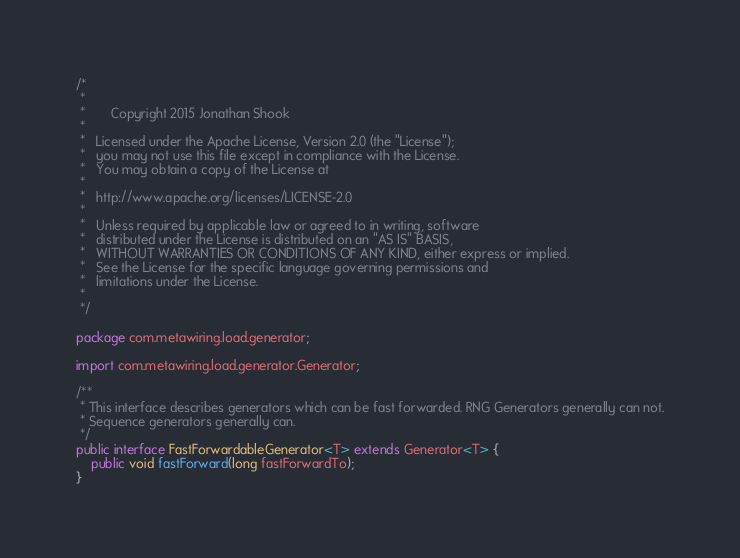<code> <loc_0><loc_0><loc_500><loc_500><_Java_>/*
 *
 *       Copyright 2015 Jonathan Shook
 *
 *   Licensed under the Apache License, Version 2.0 (the "License");
 *   you may not use this file except in compliance with the License.
 *   You may obtain a copy of the License at
 *
 *   http://www.apache.org/licenses/LICENSE-2.0
 *
 *   Unless required by applicable law or agreed to in writing, software
 *   distributed under the License is distributed on an "AS IS" BASIS,
 *   WITHOUT WARRANTIES OR CONDITIONS OF ANY KIND, either express or implied.
 *   See the License for the specific language governing permissions and
 *   limitations under the License.
 *
 */

package com.metawiring.load.generator;

import com.metawiring.load.generator.Generator;

/**
 * This interface describes generators which can be fast forwarded. RNG Generators generally can not.
 * Sequence generators generally can.
 */
public interface FastForwardableGenerator<T> extends Generator<T> {
    public void fastForward(long fastForwardTo);
}
</code> 